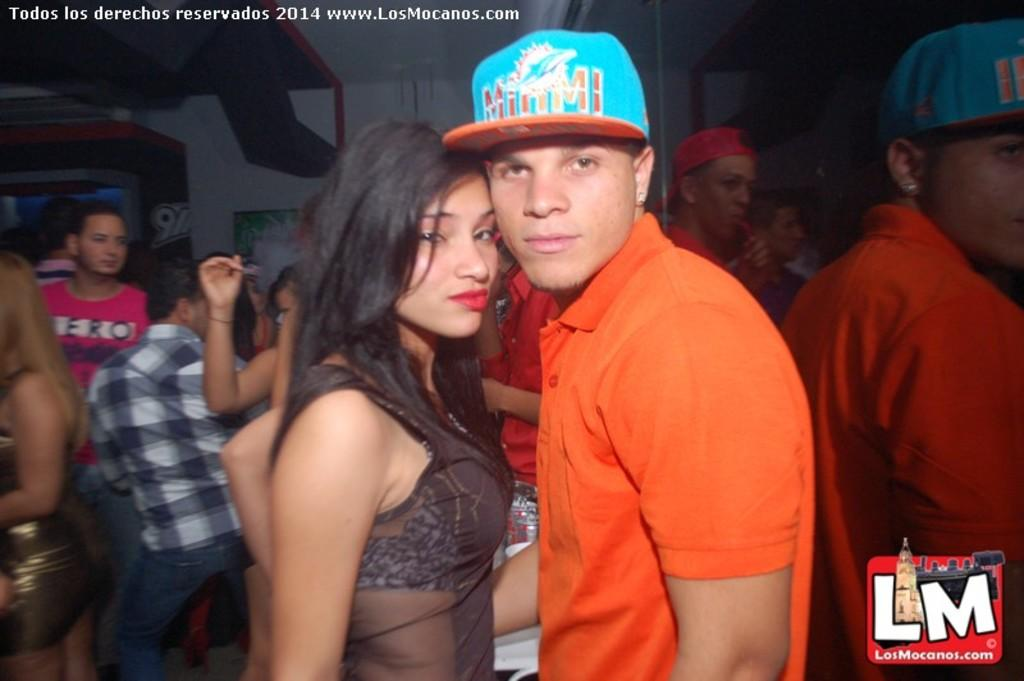Provide a one-sentence caption for the provided image. An LM logo occupies the corner of a photo depicting a young couple. 